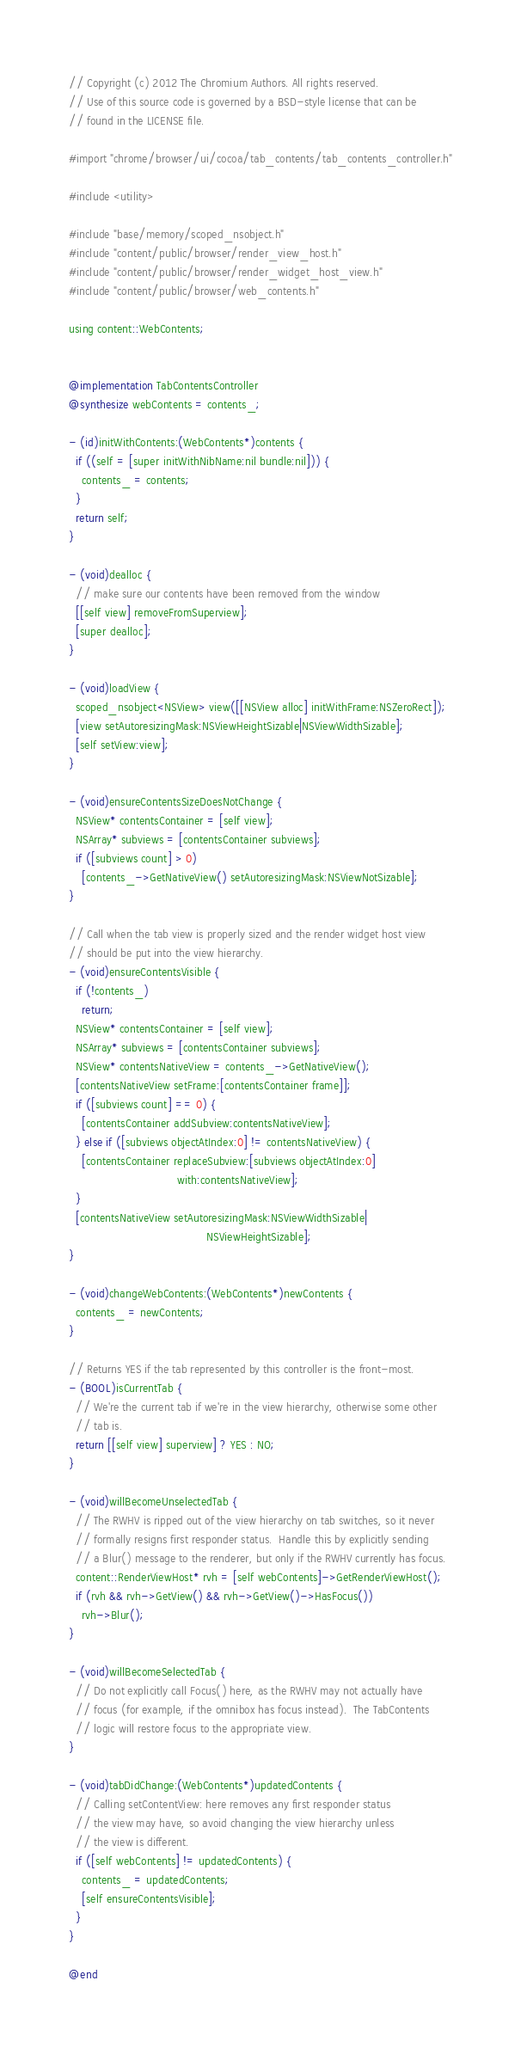Convert code to text. <code><loc_0><loc_0><loc_500><loc_500><_ObjectiveC_>// Copyright (c) 2012 The Chromium Authors. All rights reserved.
// Use of this source code is governed by a BSD-style license that can be
// found in the LICENSE file.

#import "chrome/browser/ui/cocoa/tab_contents/tab_contents_controller.h"

#include <utility>

#include "base/memory/scoped_nsobject.h"
#include "content/public/browser/render_view_host.h"
#include "content/public/browser/render_widget_host_view.h"
#include "content/public/browser/web_contents.h"

using content::WebContents;


@implementation TabContentsController
@synthesize webContents = contents_;

- (id)initWithContents:(WebContents*)contents {
  if ((self = [super initWithNibName:nil bundle:nil])) {
    contents_ = contents;
  }
  return self;
}

- (void)dealloc {
  // make sure our contents have been removed from the window
  [[self view] removeFromSuperview];
  [super dealloc];
}

- (void)loadView {
  scoped_nsobject<NSView> view([[NSView alloc] initWithFrame:NSZeroRect]);
  [view setAutoresizingMask:NSViewHeightSizable|NSViewWidthSizable];
  [self setView:view];
}

- (void)ensureContentsSizeDoesNotChange {
  NSView* contentsContainer = [self view];
  NSArray* subviews = [contentsContainer subviews];
  if ([subviews count] > 0)
    [contents_->GetNativeView() setAutoresizingMask:NSViewNotSizable];
}

// Call when the tab view is properly sized and the render widget host view
// should be put into the view hierarchy.
- (void)ensureContentsVisible {
  if (!contents_)
    return;
  NSView* contentsContainer = [self view];
  NSArray* subviews = [contentsContainer subviews];
  NSView* contentsNativeView = contents_->GetNativeView();
  [contentsNativeView setFrame:[contentsContainer frame]];
  if ([subviews count] == 0) {
    [contentsContainer addSubview:contentsNativeView];
  } else if ([subviews objectAtIndex:0] != contentsNativeView) {
    [contentsContainer replaceSubview:[subviews objectAtIndex:0]
                                 with:contentsNativeView];
  }
  [contentsNativeView setAutoresizingMask:NSViewWidthSizable|
                                          NSViewHeightSizable];
}

- (void)changeWebContents:(WebContents*)newContents {
  contents_ = newContents;
}

// Returns YES if the tab represented by this controller is the front-most.
- (BOOL)isCurrentTab {
  // We're the current tab if we're in the view hierarchy, otherwise some other
  // tab is.
  return [[self view] superview] ? YES : NO;
}

- (void)willBecomeUnselectedTab {
  // The RWHV is ripped out of the view hierarchy on tab switches, so it never
  // formally resigns first responder status.  Handle this by explicitly sending
  // a Blur() message to the renderer, but only if the RWHV currently has focus.
  content::RenderViewHost* rvh = [self webContents]->GetRenderViewHost();
  if (rvh && rvh->GetView() && rvh->GetView()->HasFocus())
    rvh->Blur();
}

- (void)willBecomeSelectedTab {
  // Do not explicitly call Focus() here, as the RWHV may not actually have
  // focus (for example, if the omnibox has focus instead).  The TabContents
  // logic will restore focus to the appropriate view.
}

- (void)tabDidChange:(WebContents*)updatedContents {
  // Calling setContentView: here removes any first responder status
  // the view may have, so avoid changing the view hierarchy unless
  // the view is different.
  if ([self webContents] != updatedContents) {
    contents_ = updatedContents;
    [self ensureContentsVisible];
  }
}

@end
</code> 